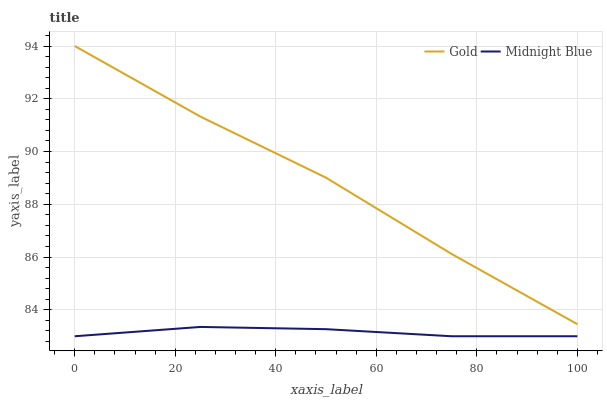Does Midnight Blue have the minimum area under the curve?
Answer yes or no. Yes. Does Gold have the maximum area under the curve?
Answer yes or no. Yes. Does Gold have the minimum area under the curve?
Answer yes or no. No. Is Midnight Blue the smoothest?
Answer yes or no. Yes. Is Gold the roughest?
Answer yes or no. Yes. Is Gold the smoothest?
Answer yes or no. No. Does Midnight Blue have the lowest value?
Answer yes or no. Yes. Does Gold have the lowest value?
Answer yes or no. No. Does Gold have the highest value?
Answer yes or no. Yes. Is Midnight Blue less than Gold?
Answer yes or no. Yes. Is Gold greater than Midnight Blue?
Answer yes or no. Yes. Does Midnight Blue intersect Gold?
Answer yes or no. No. 